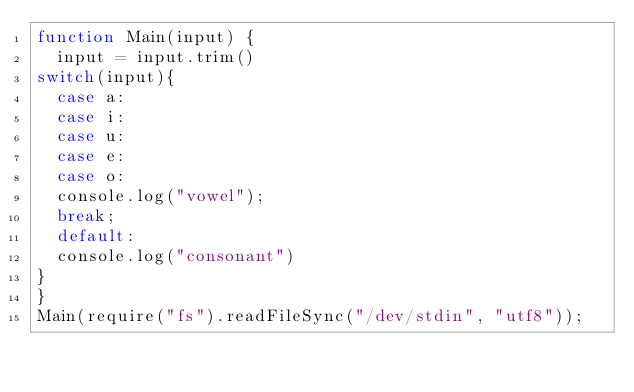<code> <loc_0><loc_0><loc_500><loc_500><_JavaScript_>function Main(input) {
  input = input.trim()
switch(input){
  case a:
  case i:
  case u:
  case e:
  case o:
  console.log("vowel");
  break;
  default:
  console.log("consonant")
}
}
Main(require("fs").readFileSync("/dev/stdin", "utf8"));</code> 